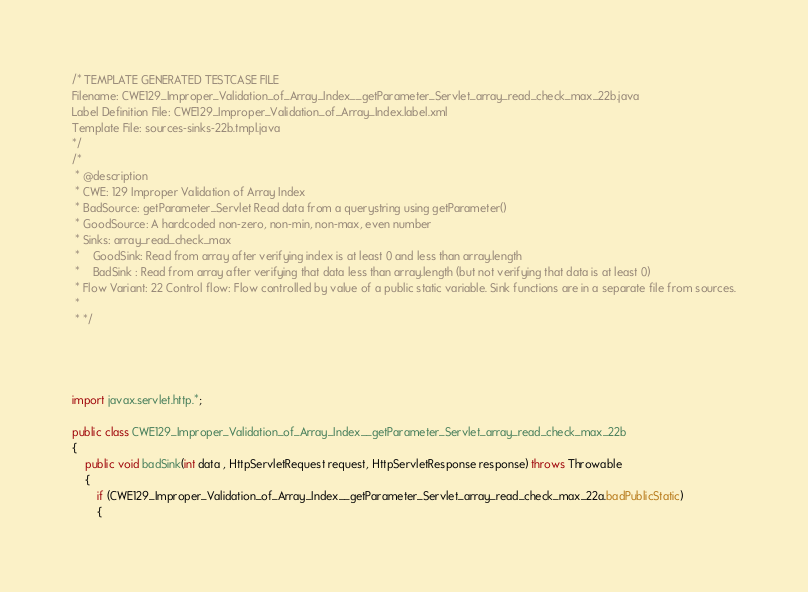Convert code to text. <code><loc_0><loc_0><loc_500><loc_500><_Java_>/* TEMPLATE GENERATED TESTCASE FILE
Filename: CWE129_Improper_Validation_of_Array_Index__getParameter_Servlet_array_read_check_max_22b.java
Label Definition File: CWE129_Improper_Validation_of_Array_Index.label.xml
Template File: sources-sinks-22b.tmpl.java
*/
/*
 * @description
 * CWE: 129 Improper Validation of Array Index
 * BadSource: getParameter_Servlet Read data from a querystring using getParameter()
 * GoodSource: A hardcoded non-zero, non-min, non-max, even number
 * Sinks: array_read_check_max
 *    GoodSink: Read from array after verifying index is at least 0 and less than array.length
 *    BadSink : Read from array after verifying that data less than array.length (but not verifying that data is at least 0)
 * Flow Variant: 22 Control flow: Flow controlled by value of a public static variable. Sink functions are in a separate file from sources.
 *
 * */




import javax.servlet.http.*;

public class CWE129_Improper_Validation_of_Array_Index__getParameter_Servlet_array_read_check_max_22b
{
    public void badSink(int data , HttpServletRequest request, HttpServletResponse response) throws Throwable
    {
        if (CWE129_Improper_Validation_of_Array_Index__getParameter_Servlet_array_read_check_max_22a.badPublicStatic)
        {</code> 